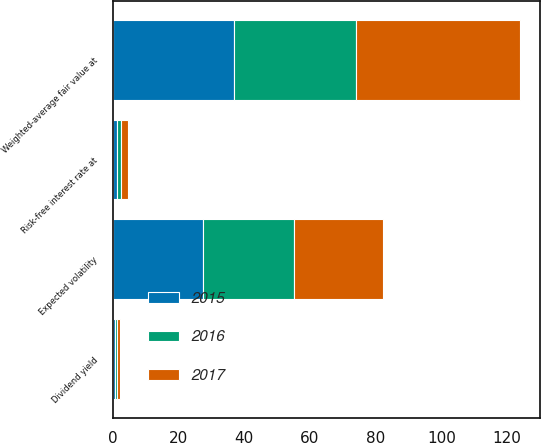<chart> <loc_0><loc_0><loc_500><loc_500><stacked_bar_chart><ecel><fcel>Weighted-average fair value at<fcel>Expected volatility<fcel>Risk-free interest rate at<fcel>Dividend yield<nl><fcel>2017<fcel>49.81<fcel>27.1<fcel>2<fcel>0.7<nl><fcel>2016<fcel>37.12<fcel>27.6<fcel>1.1<fcel>0.7<nl><fcel>2015<fcel>36.91<fcel>27.4<fcel>1.4<fcel>0.7<nl></chart> 